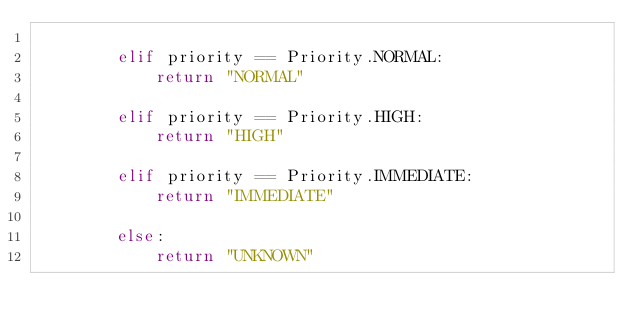<code> <loc_0><loc_0><loc_500><loc_500><_Python_>
        elif priority == Priority.NORMAL:
            return "NORMAL"

        elif priority == Priority.HIGH:
            return "HIGH"

        elif priority == Priority.IMMEDIATE:
            return "IMMEDIATE"

        else:
            return "UNKNOWN"
</code> 